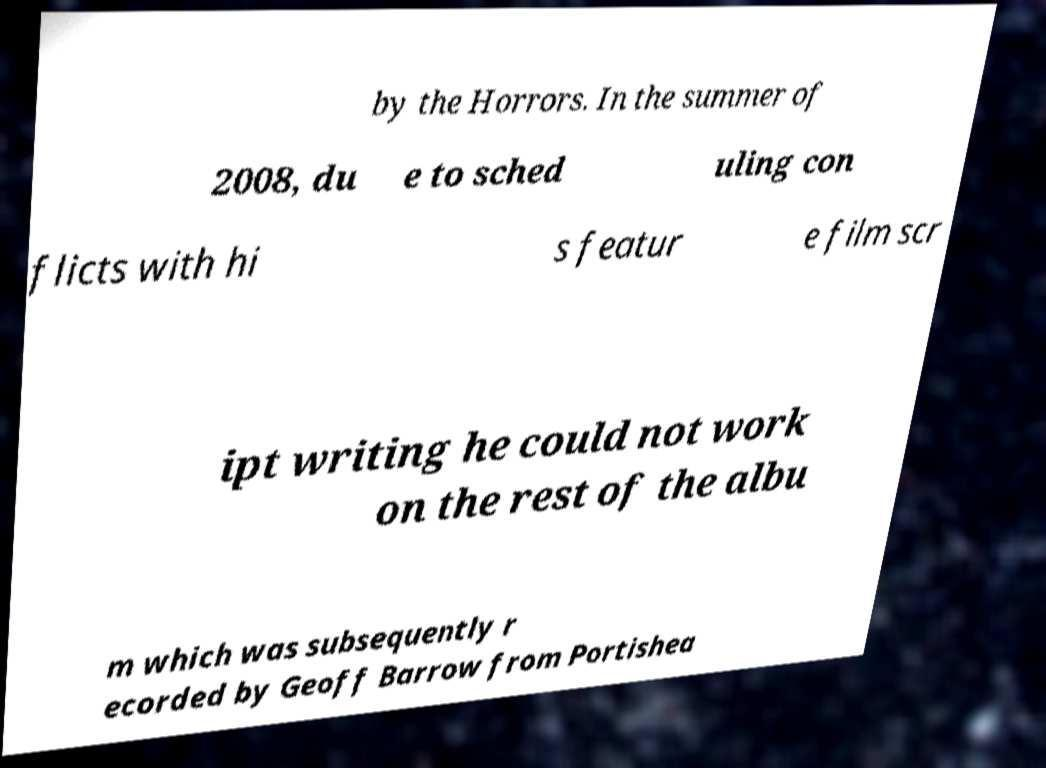Could you assist in decoding the text presented in this image and type it out clearly? by the Horrors. In the summer of 2008, du e to sched uling con flicts with hi s featur e film scr ipt writing he could not work on the rest of the albu m which was subsequently r ecorded by Geoff Barrow from Portishea 